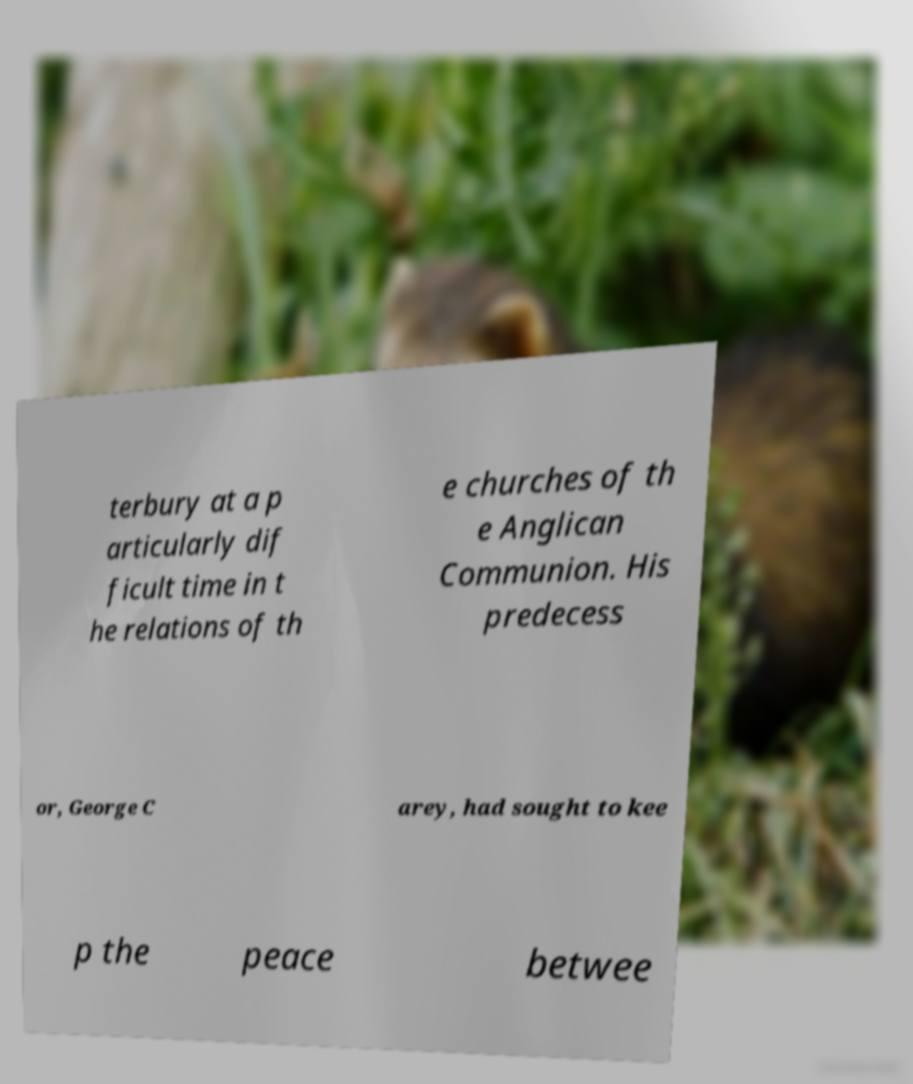Please read and relay the text visible in this image. What does it say? terbury at a p articularly dif ficult time in t he relations of th e churches of th e Anglican Communion. His predecess or, George C arey, had sought to kee p the peace betwee 